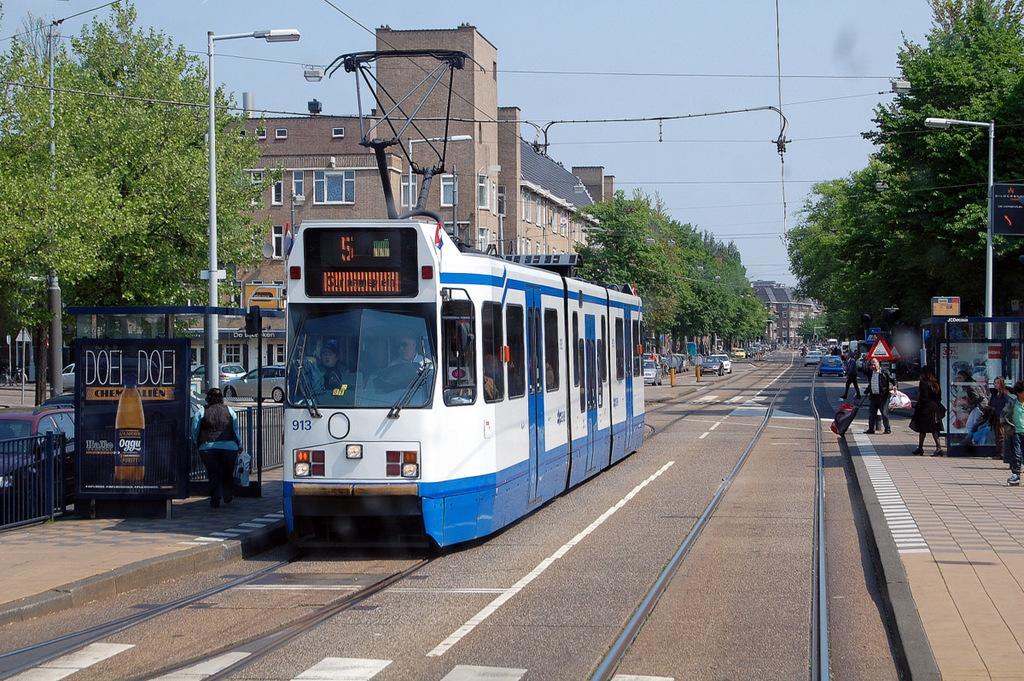How would you summarize this image in a sentence or two? The outdoor picture. The vehicles are travelling on road. This vehicle is in white and blue color. The pole with light. Far there are number of trees in green color. Sky is in blue color. Sign board. People are standing on a footpath. Fence is in black color. advertisement on a black boat. Far there are houses with blue roof top and with window. 